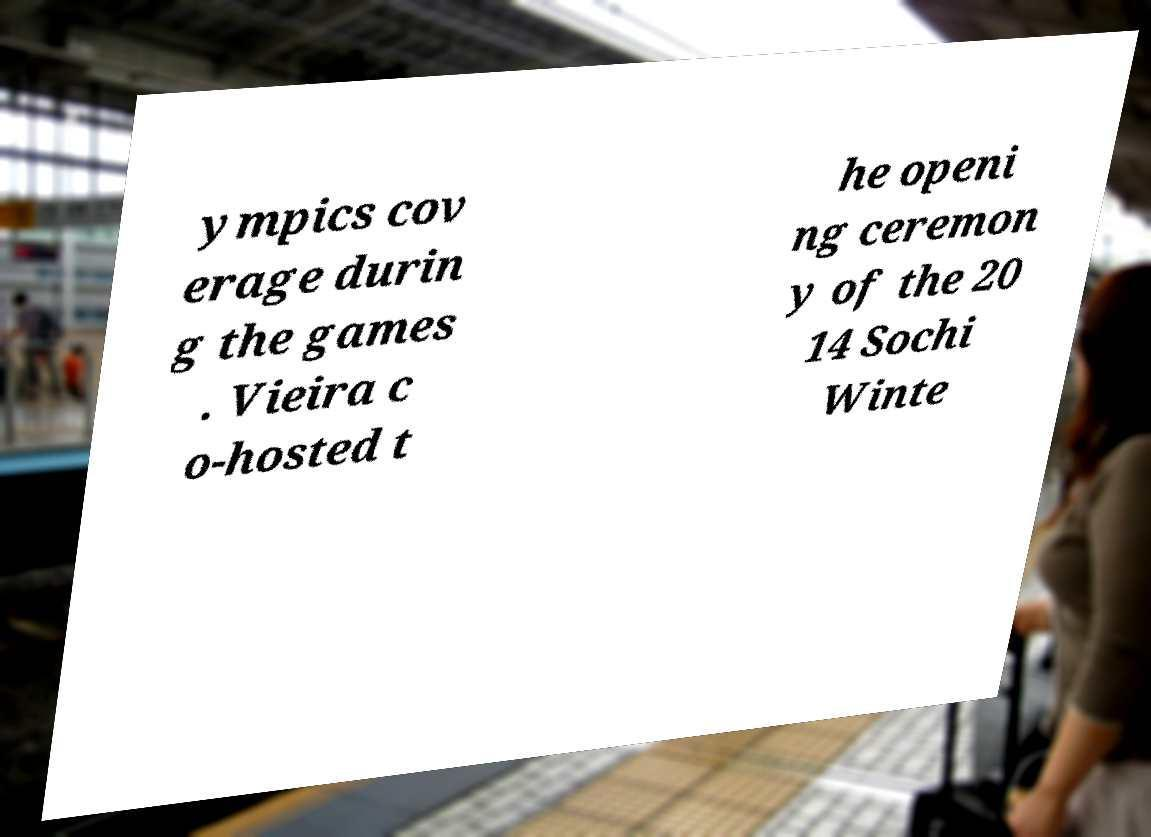Can you accurately transcribe the text from the provided image for me? ympics cov erage durin g the games . Vieira c o-hosted t he openi ng ceremon y of the 20 14 Sochi Winte 